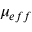<formula> <loc_0><loc_0><loc_500><loc_500>\mu _ { e f f }</formula> 